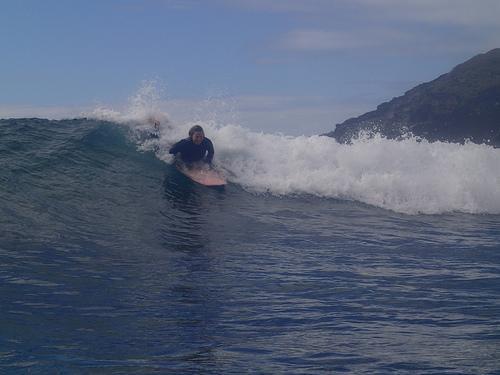How many surfers in the ocean?
Give a very brief answer. 1. How many surfboards in the photo?
Give a very brief answer. 1. How many mountains in the background?
Give a very brief answer. 1. 